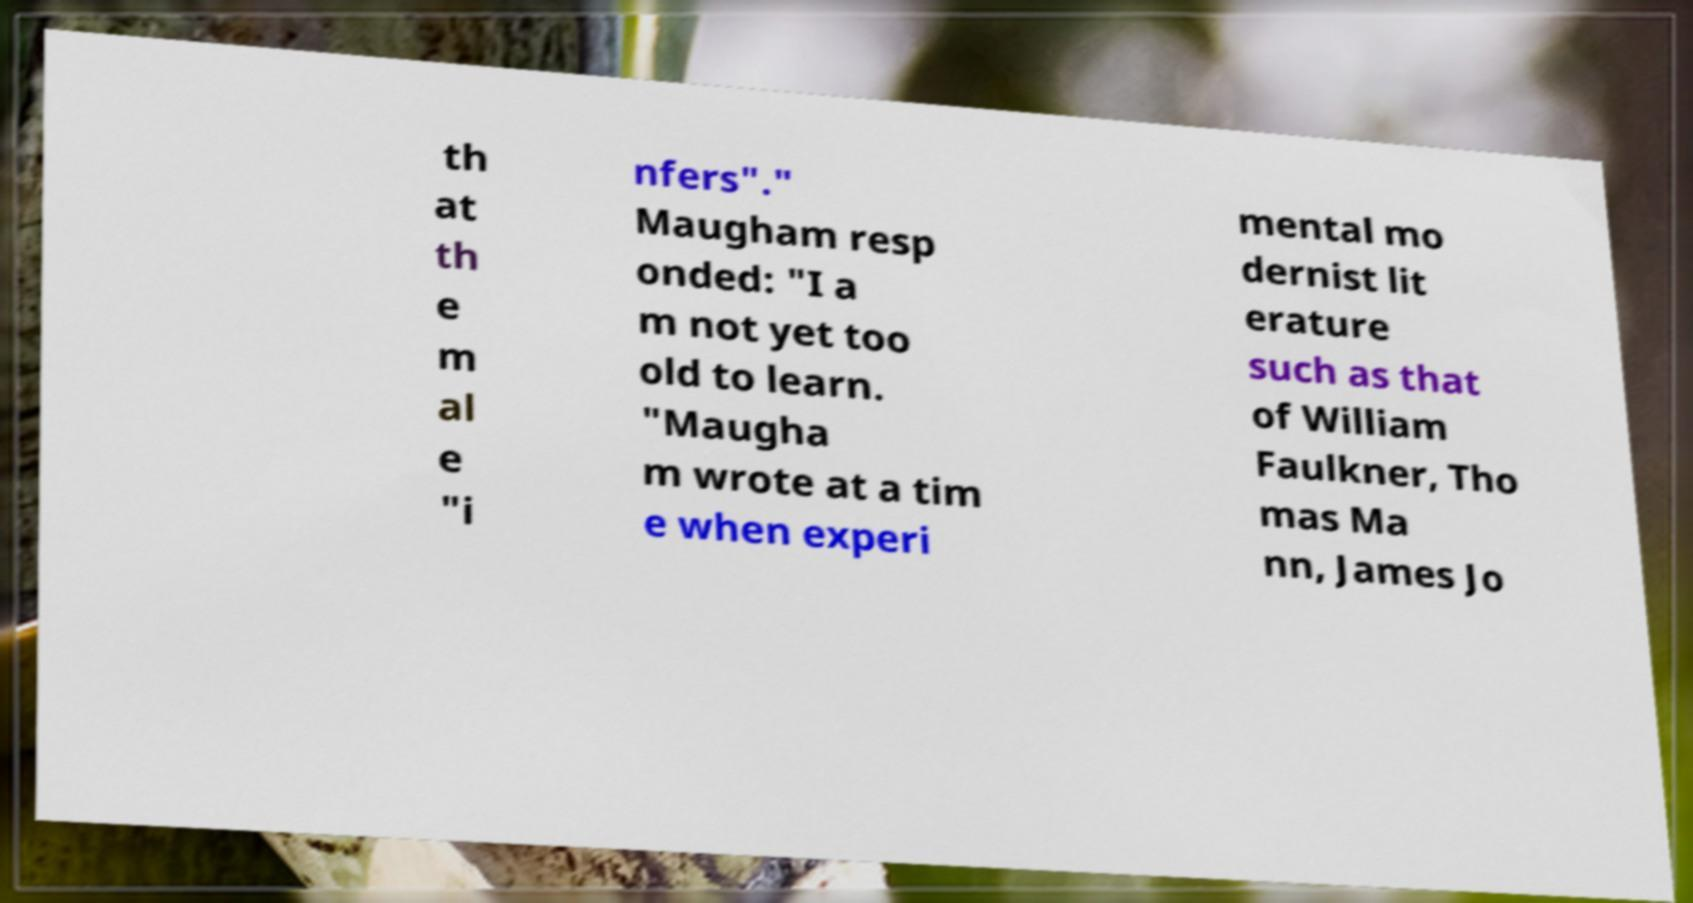Please read and relay the text visible in this image. What does it say? th at th e m al e "i nfers"." Maugham resp onded: "I a m not yet too old to learn. "Maugha m wrote at a tim e when experi mental mo dernist lit erature such as that of William Faulkner, Tho mas Ma nn, James Jo 